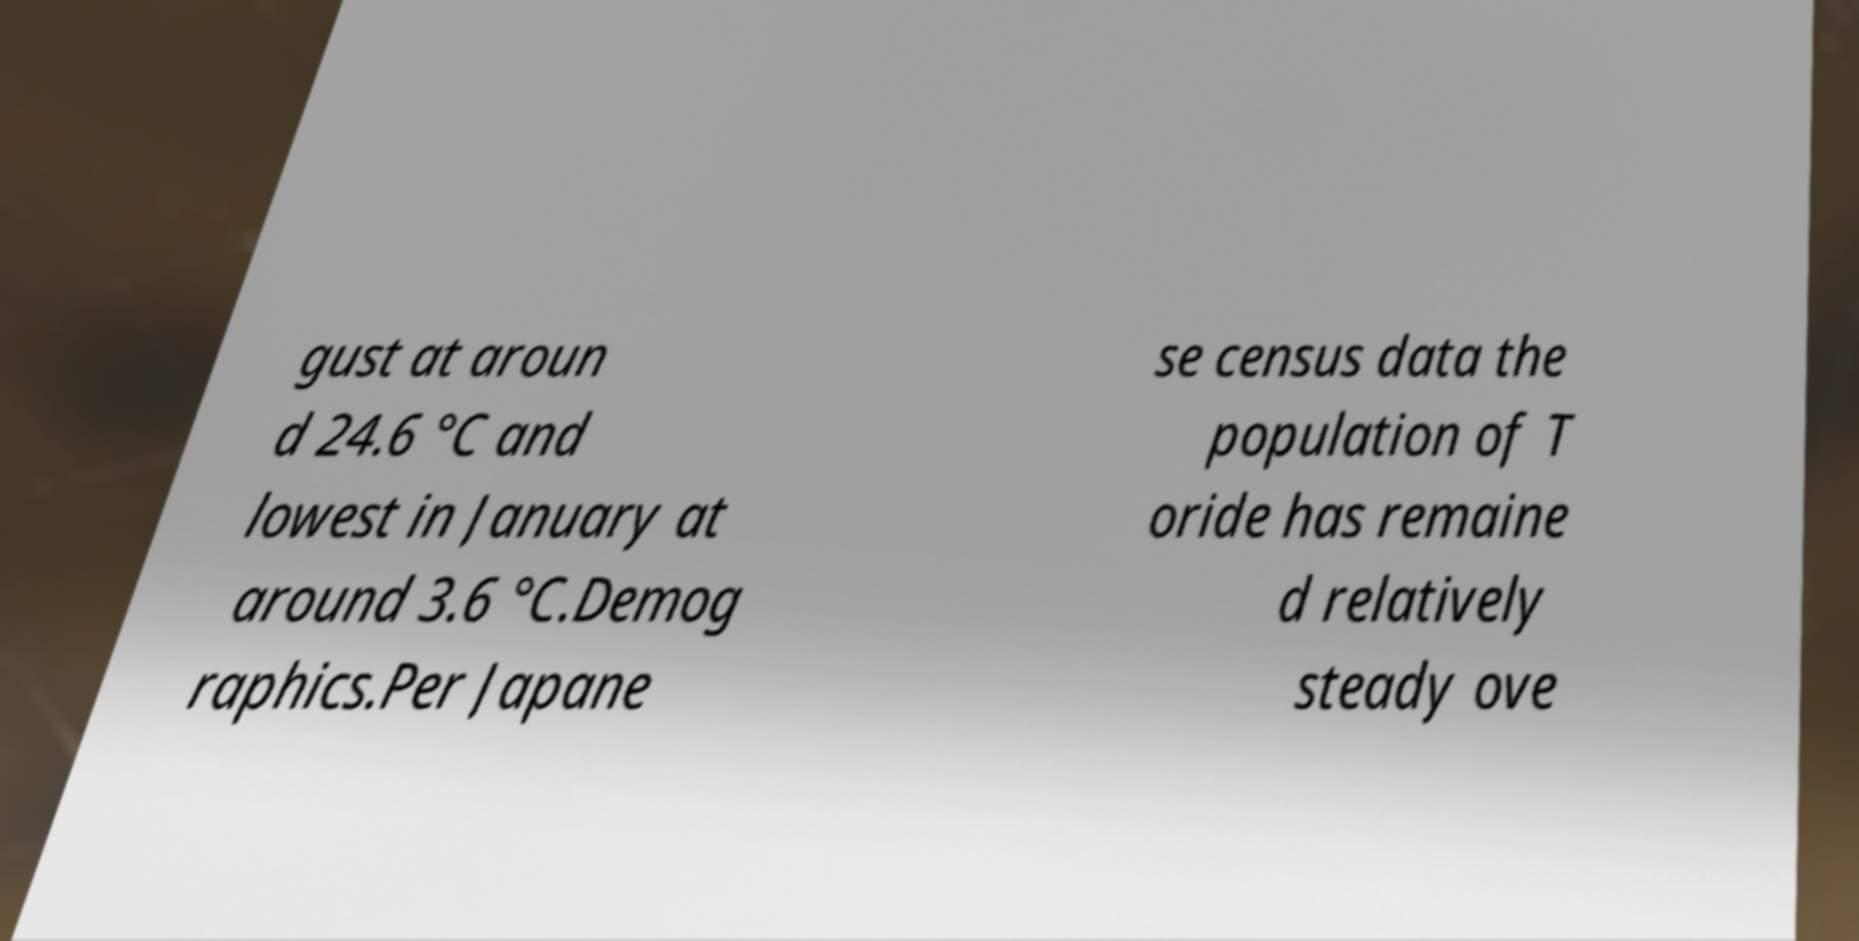For documentation purposes, I need the text within this image transcribed. Could you provide that? gust at aroun d 24.6 °C and lowest in January at around 3.6 °C.Demog raphics.Per Japane se census data the population of T oride has remaine d relatively steady ove 